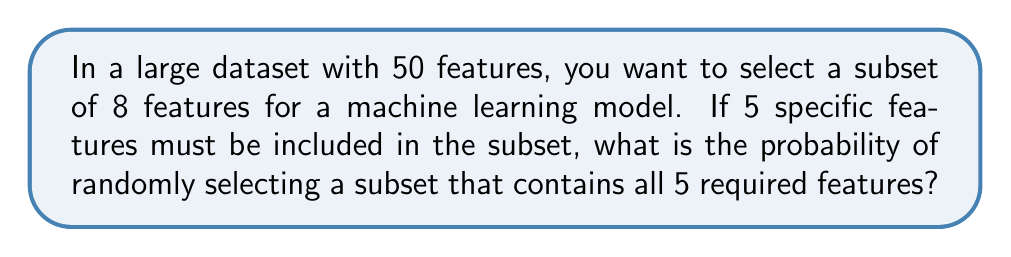Give your solution to this math problem. Let's approach this step-by-step:

1) We have a total of 50 features, and we need to select 8 of them.

2) 5 features are required to be in the subset, which means we need to select 3 more features from the remaining 45.

3) The total number of ways to select 8 features from 50 is:

   $$\binom{50}{8} = \frac{50!}{8!(50-8)!} = \frac{50!}{8!42!}$$

4) The number of ways to select 3 features from the remaining 45 is:

   $$\binom{45}{3} = \frac{45!}{3!(45-3)!} = \frac{45!}{3!42!}$$

5) The probability is the number of favorable outcomes divided by the total number of possible outcomes:

   $$P(\text{subset includes all 5 required features}) = \frac{\binom{45}{3}}{\binom{50}{8}}$$

6) Simplifying:

   $$P = \frac{\frac{45!}{3!42!}}{\frac{50!}{8!42!}} = \frac{45! \cdot 8!42!}{3!42! \cdot 50!}$$

7) The 42! cancels out:

   $$P = \frac{45! \cdot 8!}{3! \cdot 50!} = \frac{45 \cdot 44 \cdot 43 \cdot 8 \cdot 7 \cdot 6 \cdot 5 \cdot 4}{50 \cdot 49 \cdot 48 \cdot 47 \cdot 46 \cdot 3 \cdot 2 \cdot 1}$$

8) Calculating this gives us the final probability.
Answer: $\frac{1,403,325}{12,103,014} \approx 0.1159$ or about 11.59% 